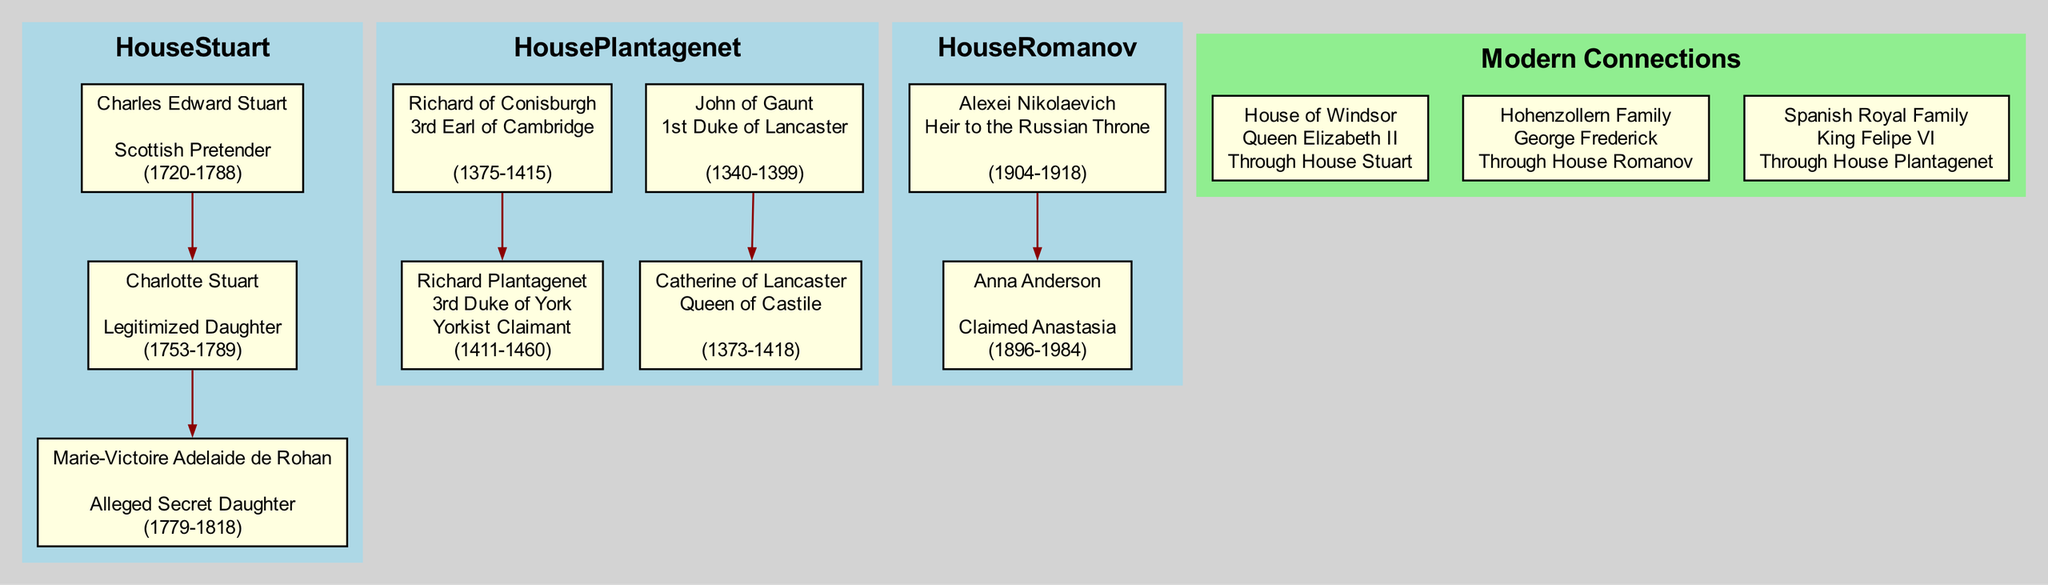What title did John of Gaunt hold? In the diagram, John of Gaunt is listed with the title "1st Duke of Lancaster". This is found under the House Plantagenet section, where his key figure details are displayed.
Answer: 1st Duke of Lancaster Who is the claimed secret daughter of Charles Edward Stuart? The diagram shows that Charlotte Stuart, who is labeled as the "Legitimized Daughter" of Charles Edward Stuart, has an offspring named Marie-Victoire Adelaide de Rohan, identified as the "Alleged Secret Daughter".
Answer: Marie-Victoire Adelaide de Rohan How many offspring does Richard Plantagenet have? From the diagram, it is evident that Richard Plantagenet, the 3rd Duke of York, has one offspring listed, which is highlighted under his details.
Answer: 1 Which royal family is connected through Catherine of Lancaster? The diagram indicates that the Spanish Royal Family connected through Catherine of Lancaster, who is noted as the "Queen of Castile". This establishes her ties with the modern political connection.
Answer: Spanish Royal Family Name a current representative of the House of Windsor. According to the diagram, the current representative of the House of Windsor is Queen Elizabeth II, as specified in the modern connections section.
Answer: Queen Elizabeth II Explain the connection between House Stuart and the House of Windsor. The diagram illustrates that the connection is made "Through House Stuart", where it states that the descendants of the Stuarts following their legitimization have led to the current representation in the House of Windsor.
Answer: Through House Stuart Which house had an heir born in 1904? In the diagram, Alexei Nikolaevich is identified as the heir to the Russian Throne, and his birth year is explicitly mentioned as 1904 under the House Romanov section.
Answer: House Romanov What claim is Charlotte Stuart associated with? Charlotte Stuart is associated with the claim labeled as "Legitimized Daughter," as indicated in the diagram under her details.
Answer: Legitimized Daughter Identify one offspring of Richard of Conisburgh. The diagram shows that Richard of Conisburgh, the 3rd Earl of Cambridge, has one offspring, Richard Plantagenet, listed as his child in the family tree structure.
Answer: Richard Plantagenet 